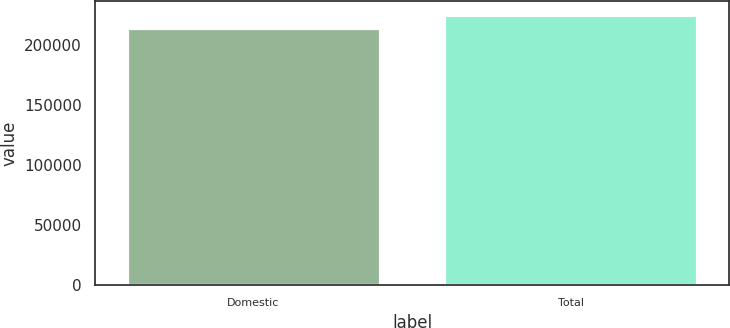Convert chart. <chart><loc_0><loc_0><loc_500><loc_500><bar_chart><fcel>Domestic<fcel>Total<nl><fcel>214283<fcel>225776<nl></chart> 